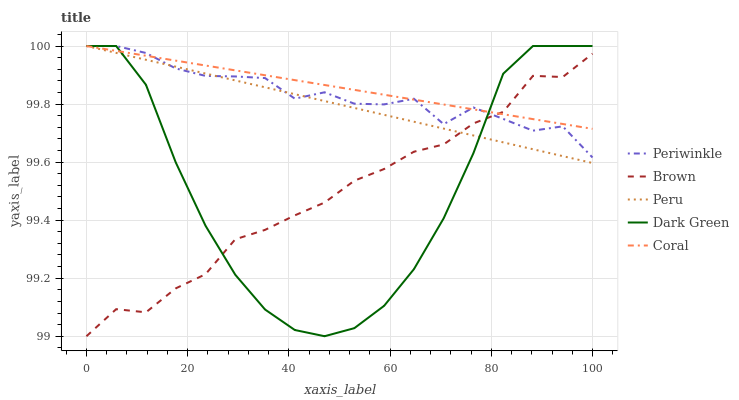Does Brown have the minimum area under the curve?
Answer yes or no. Yes. Does Coral have the maximum area under the curve?
Answer yes or no. Yes. Does Periwinkle have the minimum area under the curve?
Answer yes or no. No. Does Periwinkle have the maximum area under the curve?
Answer yes or no. No. Is Coral the smoothest?
Answer yes or no. Yes. Is Dark Green the roughest?
Answer yes or no. Yes. Is Periwinkle the smoothest?
Answer yes or no. No. Is Periwinkle the roughest?
Answer yes or no. No. Does Brown have the lowest value?
Answer yes or no. Yes. Does Periwinkle have the lowest value?
Answer yes or no. No. Does Dark Green have the highest value?
Answer yes or no. Yes. Does Peru intersect Coral?
Answer yes or no. Yes. Is Peru less than Coral?
Answer yes or no. No. Is Peru greater than Coral?
Answer yes or no. No. 